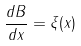Convert formula to latex. <formula><loc_0><loc_0><loc_500><loc_500>\frac { d B } { d x } = \xi ( x )</formula> 